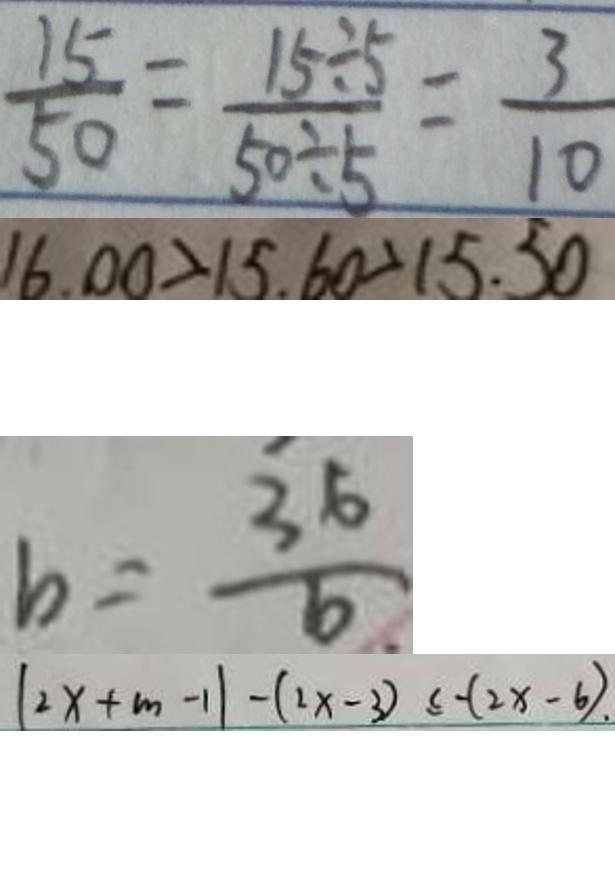<formula> <loc_0><loc_0><loc_500><loc_500>\frac { 1 5 } { 5 0 } = \frac { 1 5 \div 5 } { 5 0 \div 5 } = \frac { 3 } { 1 0 } 
 1 6 . 0 0 > 1 5 . 6 0 > 1 5 . 5 0 
 b = \frac { 3 6 } { 6 } 
 ( 2 x + m - 1 ) - ( 2 x - 3 ) \leq - ( 2 x - 6 ) .</formula> 